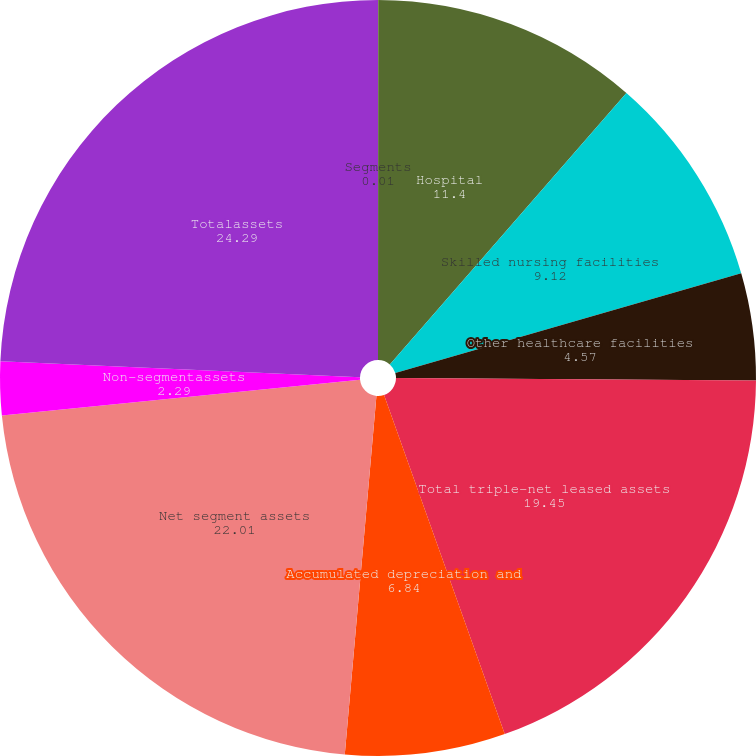Convert chart. <chart><loc_0><loc_0><loc_500><loc_500><pie_chart><fcel>Segments<fcel>Hospital<fcel>Skilled nursing facilities<fcel>Other healthcare facilities<fcel>Total triple-net leased assets<fcel>Accumulated depreciation and<fcel>Net segment assets<fcel>Non-segmentassets<fcel>Totalassets<nl><fcel>0.01%<fcel>11.4%<fcel>9.12%<fcel>4.57%<fcel>19.45%<fcel>6.84%<fcel>22.01%<fcel>2.29%<fcel>24.29%<nl></chart> 